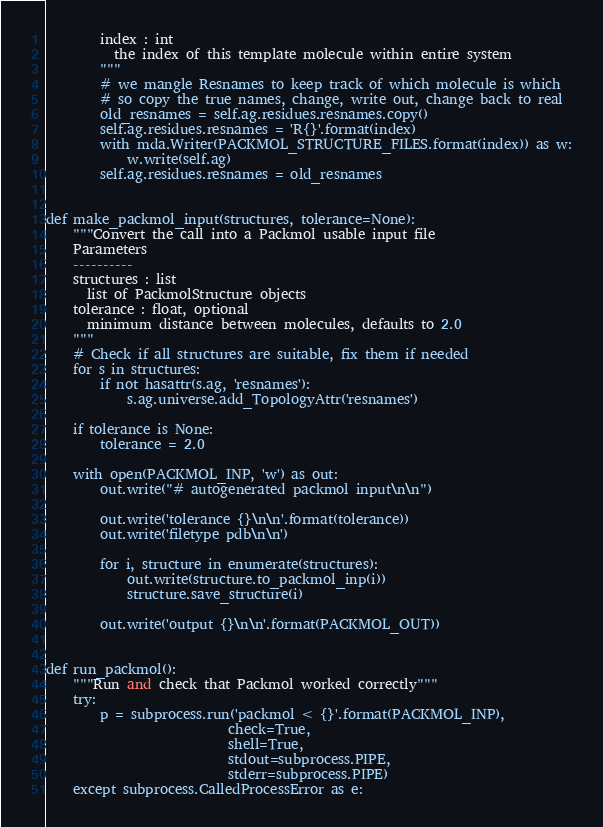<code> <loc_0><loc_0><loc_500><loc_500><_Python_>        index : int
          the index of this template molecule within entire system
        """
        # we mangle Resnames to keep track of which molecule is which
        # so copy the true names, change, write out, change back to real
        old_resnames = self.ag.residues.resnames.copy()
        self.ag.residues.resnames = 'R{}'.format(index)
        with mda.Writer(PACKMOL_STRUCTURE_FILES.format(index)) as w:
            w.write(self.ag)
        self.ag.residues.resnames = old_resnames


def make_packmol_input(structures, tolerance=None):
    """Convert the call into a Packmol usable input file
    Parameters
    ----------
    structures : list
      list of PackmolStructure objects
    tolerance : float, optional
      minimum distance between molecules, defaults to 2.0
    """
    # Check if all structures are suitable, fix them if needed
    for s in structures:
        if not hasattr(s.ag, 'resnames'):
            s.ag.universe.add_TopologyAttr('resnames')

    if tolerance is None:
        tolerance = 2.0

    with open(PACKMOL_INP, 'w') as out:
        out.write("# autogenerated packmol input\n\n")

        out.write('tolerance {}\n\n'.format(tolerance))
        out.write('filetype pdb\n\n')

        for i, structure in enumerate(structures):
            out.write(structure.to_packmol_inp(i))
            structure.save_structure(i)

        out.write('output {}\n\n'.format(PACKMOL_OUT))


def run_packmol():
    """Run and check that Packmol worked correctly"""
    try:
        p = subprocess.run('packmol < {}'.format(PACKMOL_INP),
                           check=True,
                           shell=True,
                           stdout=subprocess.PIPE,
                           stderr=subprocess.PIPE)
    except subprocess.CalledProcessError as e:</code> 